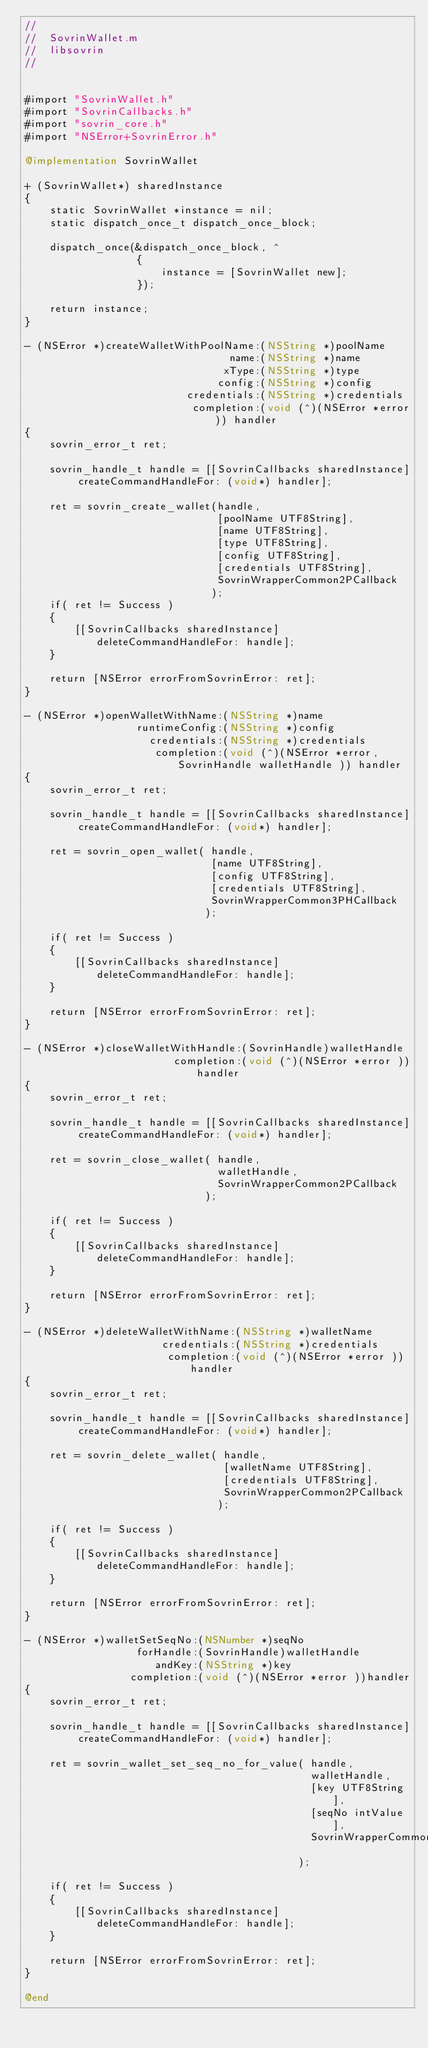Convert code to text. <code><loc_0><loc_0><loc_500><loc_500><_ObjectiveC_>//
//  SovrinWallet.m
//  libsovrin
//


#import "SovrinWallet.h"
#import "SovrinCallbacks.h"
#import "sovrin_core.h"
#import "NSError+SovrinError.h"

@implementation SovrinWallet

+ (SovrinWallet*) sharedInstance
{
    static SovrinWallet *instance = nil;
    static dispatch_once_t dispatch_once_block;
    
    dispatch_once(&dispatch_once_block, ^
                  {
                      instance = [SovrinWallet new];
                  });
    
    return instance;
}

- (NSError *)createWalletWithPoolName:(NSString *)poolName
                                 name:(NSString *)name
                                xType:(NSString *)type
                               config:(NSString *)config
                          credentials:(NSString *)credentials
                           completion:(void (^)(NSError *error)) handler
{
    sovrin_error_t ret;
    
    sovrin_handle_t handle = [[SovrinCallbacks sharedInstance] createCommandHandleFor: (void*) handler];
    
    ret = sovrin_create_wallet(handle,
                               [poolName UTF8String],
                               [name UTF8String],
                               [type UTF8String],
                               [config UTF8String],
                               [credentials UTF8String],
                               SovrinWrapperCommon2PCallback
                              );
    if( ret != Success )
    {
        [[SovrinCallbacks sharedInstance] deleteCommandHandleFor: handle];
    }
    
    return [NSError errorFromSovrinError: ret];
}

- (NSError *)openWalletWithName:(NSString *)name
                  runtimeConfig:(NSString *)config
                    credentials:(NSString *)credentials
                     completion:(void (^)(NSError *error, SovrinHandle walletHandle )) handler
{
    sovrin_error_t ret;
    
    sovrin_handle_t handle = [[SovrinCallbacks sharedInstance] createCommandHandleFor: (void*) handler];
    
    ret = sovrin_open_wallet( handle,
                              [name UTF8String],
                              [config UTF8String],
                              [credentials UTF8String],
                              SovrinWrapperCommon3PHCallback
                             );
    
    if( ret != Success )
    {
        [[SovrinCallbacks sharedInstance] deleteCommandHandleFor: handle];
    }
    
    return [NSError errorFromSovrinError: ret];
}

- (NSError *)closeWalletWithHandle:(SovrinHandle)walletHandle
                        completion:(void (^)(NSError *error ))handler
{
    sovrin_error_t ret;
    
    sovrin_handle_t handle = [[SovrinCallbacks sharedInstance] createCommandHandleFor: (void*) handler];
    
    ret = sovrin_close_wallet( handle,
                               walletHandle,
                               SovrinWrapperCommon2PCallback
                             );
    
    if( ret != Success )
    {
        [[SovrinCallbacks sharedInstance] deleteCommandHandleFor: handle];
    }
    
    return [NSError errorFromSovrinError: ret];
}

- (NSError *)deleteWalletWithName:(NSString *)walletName
                      credentials:(NSString *)credentials
                       completion:(void (^)(NSError *error ))handler
{
    sovrin_error_t ret;
    
    sovrin_handle_t handle = [[SovrinCallbacks sharedInstance] createCommandHandleFor: (void*) handler];
    
    ret = sovrin_delete_wallet( handle,
                                [walletName UTF8String],
                                [credentials UTF8String],
                                SovrinWrapperCommon2PCallback
                               );
    
    if( ret != Success )
    {
        [[SovrinCallbacks sharedInstance] deleteCommandHandleFor: handle];
    }
    
    return [NSError errorFromSovrinError: ret];
}

- (NSError *)walletSetSeqNo:(NSNumber *)seqNo
                  forHandle:(SovrinHandle)walletHandle
                     andKey:(NSString *)key
                 completion:(void (^)(NSError *error ))handler
{
    sovrin_error_t ret;
    
    sovrin_handle_t handle = [[SovrinCallbacks sharedInstance] createCommandHandleFor: (void*) handler];
    
    ret = sovrin_wallet_set_seq_no_for_value( handle,
                                              walletHandle,
                                              [key UTF8String],
                                              [seqNo intValue],
                                              SovrinWrapperCommon2PCallback
                                            );
    
    if( ret != Success )
    {
        [[SovrinCallbacks sharedInstance] deleteCommandHandleFor: handle];
    }
    
    return [NSError errorFromSovrinError: ret];
}

@end
</code> 